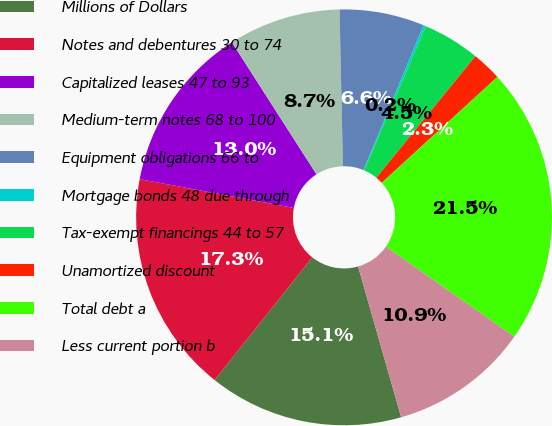<chart> <loc_0><loc_0><loc_500><loc_500><pie_chart><fcel>Millions of Dollars<fcel>Notes and debentures 30 to 74<fcel>Capitalized leases 47 to 93<fcel>Medium-term notes 68 to 100<fcel>Equipment obligations 66 to<fcel>Mortgage bonds 48 due through<fcel>Tax-exempt financings 44 to 57<fcel>Unamortized discount<fcel>Total debt a<fcel>Less current portion b<nl><fcel>15.12%<fcel>17.25%<fcel>12.99%<fcel>8.72%<fcel>6.59%<fcel>0.19%<fcel>4.45%<fcel>2.32%<fcel>21.52%<fcel>10.85%<nl></chart> 